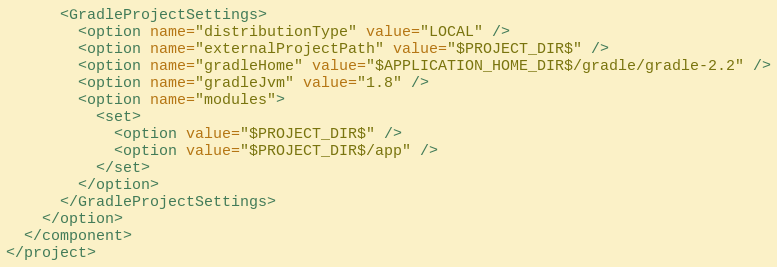<code> <loc_0><loc_0><loc_500><loc_500><_XML_>      <GradleProjectSettings>
        <option name="distributionType" value="LOCAL" />
        <option name="externalProjectPath" value="$PROJECT_DIR$" />
        <option name="gradleHome" value="$APPLICATION_HOME_DIR$/gradle/gradle-2.2" />
        <option name="gradleJvm" value="1.8" />
        <option name="modules">
          <set>
            <option value="$PROJECT_DIR$" />
            <option value="$PROJECT_DIR$/app" />
          </set>
        </option>
      </GradleProjectSettings>
    </option>
  </component>
</project></code> 